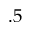Convert formula to latex. <formula><loc_0><loc_0><loc_500><loc_500>. 5</formula> 